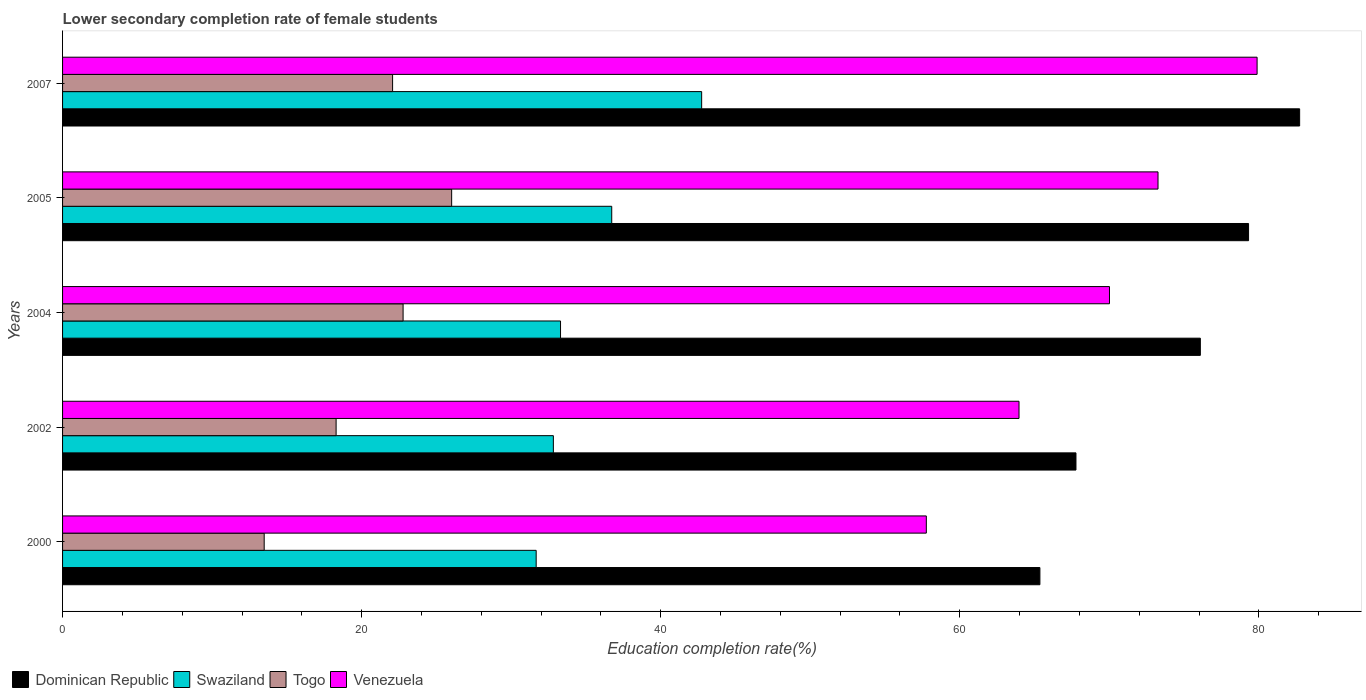How many different coloured bars are there?
Your answer should be very brief. 4. Are the number of bars per tick equal to the number of legend labels?
Give a very brief answer. Yes. Are the number of bars on each tick of the Y-axis equal?
Provide a short and direct response. Yes. How many bars are there on the 5th tick from the top?
Your answer should be very brief. 4. How many bars are there on the 5th tick from the bottom?
Keep it short and to the point. 4. In how many cases, is the number of bars for a given year not equal to the number of legend labels?
Offer a very short reply. 0. What is the lower secondary completion rate of female students in Swaziland in 2005?
Offer a terse response. 36.73. Across all years, what is the maximum lower secondary completion rate of female students in Venezuela?
Your answer should be compact. 79.89. Across all years, what is the minimum lower secondary completion rate of female students in Swaziland?
Ensure brevity in your answer.  31.67. What is the total lower secondary completion rate of female students in Swaziland in the graph?
Your answer should be compact. 177.26. What is the difference between the lower secondary completion rate of female students in Venezuela in 2000 and that in 2002?
Make the answer very short. -6.2. What is the difference between the lower secondary completion rate of female students in Togo in 2005 and the lower secondary completion rate of female students in Dominican Republic in 2002?
Ensure brevity in your answer.  -41.75. What is the average lower secondary completion rate of female students in Togo per year?
Offer a very short reply. 20.53. In the year 2005, what is the difference between the lower secondary completion rate of female students in Swaziland and lower secondary completion rate of female students in Venezuela?
Offer a very short reply. -36.53. In how many years, is the lower secondary completion rate of female students in Togo greater than 56 %?
Keep it short and to the point. 0. What is the ratio of the lower secondary completion rate of female students in Venezuela in 2000 to that in 2007?
Offer a terse response. 0.72. Is the difference between the lower secondary completion rate of female students in Swaziland in 2000 and 2005 greater than the difference between the lower secondary completion rate of female students in Venezuela in 2000 and 2005?
Offer a very short reply. Yes. What is the difference between the highest and the second highest lower secondary completion rate of female students in Venezuela?
Your answer should be compact. 6.63. What is the difference between the highest and the lowest lower secondary completion rate of female students in Dominican Republic?
Give a very brief answer. 17.37. In how many years, is the lower secondary completion rate of female students in Venezuela greater than the average lower secondary completion rate of female students in Venezuela taken over all years?
Ensure brevity in your answer.  3. Is it the case that in every year, the sum of the lower secondary completion rate of female students in Togo and lower secondary completion rate of female students in Venezuela is greater than the sum of lower secondary completion rate of female students in Swaziland and lower secondary completion rate of female students in Dominican Republic?
Your answer should be very brief. No. What does the 2nd bar from the top in 2004 represents?
Provide a succinct answer. Togo. What does the 2nd bar from the bottom in 2007 represents?
Give a very brief answer. Swaziland. Is it the case that in every year, the sum of the lower secondary completion rate of female students in Swaziland and lower secondary completion rate of female students in Togo is greater than the lower secondary completion rate of female students in Venezuela?
Ensure brevity in your answer.  No. Are all the bars in the graph horizontal?
Provide a succinct answer. Yes. Where does the legend appear in the graph?
Offer a very short reply. Bottom left. How many legend labels are there?
Provide a short and direct response. 4. How are the legend labels stacked?
Ensure brevity in your answer.  Horizontal. What is the title of the graph?
Offer a terse response. Lower secondary completion rate of female students. Does "Kiribati" appear as one of the legend labels in the graph?
Give a very brief answer. No. What is the label or title of the X-axis?
Your answer should be compact. Education completion rate(%). What is the Education completion rate(%) of Dominican Republic in 2000?
Provide a short and direct response. 65.36. What is the Education completion rate(%) in Swaziland in 2000?
Offer a very short reply. 31.67. What is the Education completion rate(%) in Togo in 2000?
Your answer should be very brief. 13.48. What is the Education completion rate(%) in Venezuela in 2000?
Your response must be concise. 57.76. What is the Education completion rate(%) in Dominican Republic in 2002?
Provide a short and direct response. 67.77. What is the Education completion rate(%) in Swaziland in 2002?
Your answer should be very brief. 32.82. What is the Education completion rate(%) of Togo in 2002?
Ensure brevity in your answer.  18.29. What is the Education completion rate(%) of Venezuela in 2002?
Make the answer very short. 63.96. What is the Education completion rate(%) of Dominican Republic in 2004?
Make the answer very short. 76.09. What is the Education completion rate(%) of Swaziland in 2004?
Your answer should be very brief. 33.3. What is the Education completion rate(%) in Togo in 2004?
Offer a terse response. 22.77. What is the Education completion rate(%) of Venezuela in 2004?
Offer a very short reply. 70.01. What is the Education completion rate(%) in Dominican Republic in 2005?
Provide a succinct answer. 79.31. What is the Education completion rate(%) in Swaziland in 2005?
Your answer should be compact. 36.73. What is the Education completion rate(%) of Togo in 2005?
Offer a very short reply. 26.02. What is the Education completion rate(%) in Venezuela in 2005?
Keep it short and to the point. 73.26. What is the Education completion rate(%) in Dominican Republic in 2007?
Provide a short and direct response. 82.73. What is the Education completion rate(%) in Swaziland in 2007?
Offer a terse response. 42.74. What is the Education completion rate(%) of Togo in 2007?
Provide a succinct answer. 22.07. What is the Education completion rate(%) in Venezuela in 2007?
Your answer should be very brief. 79.89. Across all years, what is the maximum Education completion rate(%) of Dominican Republic?
Provide a short and direct response. 82.73. Across all years, what is the maximum Education completion rate(%) of Swaziland?
Provide a succinct answer. 42.74. Across all years, what is the maximum Education completion rate(%) of Togo?
Make the answer very short. 26.02. Across all years, what is the maximum Education completion rate(%) in Venezuela?
Ensure brevity in your answer.  79.89. Across all years, what is the minimum Education completion rate(%) of Dominican Republic?
Ensure brevity in your answer.  65.36. Across all years, what is the minimum Education completion rate(%) of Swaziland?
Make the answer very short. 31.67. Across all years, what is the minimum Education completion rate(%) of Togo?
Provide a short and direct response. 13.48. Across all years, what is the minimum Education completion rate(%) of Venezuela?
Provide a succinct answer. 57.76. What is the total Education completion rate(%) of Dominican Republic in the graph?
Offer a very short reply. 371.27. What is the total Education completion rate(%) in Swaziland in the graph?
Your answer should be compact. 177.26. What is the total Education completion rate(%) of Togo in the graph?
Your answer should be very brief. 102.64. What is the total Education completion rate(%) in Venezuela in the graph?
Ensure brevity in your answer.  344.89. What is the difference between the Education completion rate(%) of Dominican Republic in 2000 and that in 2002?
Make the answer very short. -2.41. What is the difference between the Education completion rate(%) of Swaziland in 2000 and that in 2002?
Ensure brevity in your answer.  -1.15. What is the difference between the Education completion rate(%) of Togo in 2000 and that in 2002?
Provide a succinct answer. -4.81. What is the difference between the Education completion rate(%) in Venezuela in 2000 and that in 2002?
Give a very brief answer. -6.2. What is the difference between the Education completion rate(%) in Dominican Republic in 2000 and that in 2004?
Offer a very short reply. -10.73. What is the difference between the Education completion rate(%) in Swaziland in 2000 and that in 2004?
Make the answer very short. -1.63. What is the difference between the Education completion rate(%) of Togo in 2000 and that in 2004?
Offer a terse response. -9.29. What is the difference between the Education completion rate(%) in Venezuela in 2000 and that in 2004?
Your answer should be very brief. -12.25. What is the difference between the Education completion rate(%) in Dominican Republic in 2000 and that in 2005?
Your response must be concise. -13.95. What is the difference between the Education completion rate(%) of Swaziland in 2000 and that in 2005?
Your answer should be very brief. -5.05. What is the difference between the Education completion rate(%) of Togo in 2000 and that in 2005?
Offer a very short reply. -12.54. What is the difference between the Education completion rate(%) in Venezuela in 2000 and that in 2005?
Your answer should be very brief. -15.49. What is the difference between the Education completion rate(%) in Dominican Republic in 2000 and that in 2007?
Your answer should be compact. -17.37. What is the difference between the Education completion rate(%) in Swaziland in 2000 and that in 2007?
Offer a terse response. -11.07. What is the difference between the Education completion rate(%) in Togo in 2000 and that in 2007?
Keep it short and to the point. -8.59. What is the difference between the Education completion rate(%) in Venezuela in 2000 and that in 2007?
Give a very brief answer. -22.12. What is the difference between the Education completion rate(%) of Dominican Republic in 2002 and that in 2004?
Provide a short and direct response. -8.32. What is the difference between the Education completion rate(%) of Swaziland in 2002 and that in 2004?
Your answer should be very brief. -0.48. What is the difference between the Education completion rate(%) in Togo in 2002 and that in 2004?
Your answer should be very brief. -4.48. What is the difference between the Education completion rate(%) of Venezuela in 2002 and that in 2004?
Offer a very short reply. -6.05. What is the difference between the Education completion rate(%) of Dominican Republic in 2002 and that in 2005?
Give a very brief answer. -11.54. What is the difference between the Education completion rate(%) in Swaziland in 2002 and that in 2005?
Offer a very short reply. -3.9. What is the difference between the Education completion rate(%) of Togo in 2002 and that in 2005?
Give a very brief answer. -7.73. What is the difference between the Education completion rate(%) in Venezuela in 2002 and that in 2005?
Provide a succinct answer. -9.3. What is the difference between the Education completion rate(%) of Dominican Republic in 2002 and that in 2007?
Make the answer very short. -14.96. What is the difference between the Education completion rate(%) in Swaziland in 2002 and that in 2007?
Offer a terse response. -9.92. What is the difference between the Education completion rate(%) in Togo in 2002 and that in 2007?
Give a very brief answer. -3.78. What is the difference between the Education completion rate(%) of Venezuela in 2002 and that in 2007?
Offer a terse response. -15.92. What is the difference between the Education completion rate(%) of Dominican Republic in 2004 and that in 2005?
Your answer should be very brief. -3.23. What is the difference between the Education completion rate(%) in Swaziland in 2004 and that in 2005?
Give a very brief answer. -3.42. What is the difference between the Education completion rate(%) in Togo in 2004 and that in 2005?
Make the answer very short. -3.25. What is the difference between the Education completion rate(%) in Venezuela in 2004 and that in 2005?
Make the answer very short. -3.24. What is the difference between the Education completion rate(%) of Dominican Republic in 2004 and that in 2007?
Your response must be concise. -6.64. What is the difference between the Education completion rate(%) of Swaziland in 2004 and that in 2007?
Your response must be concise. -9.44. What is the difference between the Education completion rate(%) of Togo in 2004 and that in 2007?
Offer a terse response. 0.7. What is the difference between the Education completion rate(%) in Venezuela in 2004 and that in 2007?
Your answer should be compact. -9.87. What is the difference between the Education completion rate(%) of Dominican Republic in 2005 and that in 2007?
Offer a terse response. -3.42. What is the difference between the Education completion rate(%) of Swaziland in 2005 and that in 2007?
Your response must be concise. -6.01. What is the difference between the Education completion rate(%) of Togo in 2005 and that in 2007?
Provide a short and direct response. 3.95. What is the difference between the Education completion rate(%) of Venezuela in 2005 and that in 2007?
Keep it short and to the point. -6.63. What is the difference between the Education completion rate(%) of Dominican Republic in 2000 and the Education completion rate(%) of Swaziland in 2002?
Provide a short and direct response. 32.54. What is the difference between the Education completion rate(%) in Dominican Republic in 2000 and the Education completion rate(%) in Togo in 2002?
Offer a terse response. 47.07. What is the difference between the Education completion rate(%) in Dominican Republic in 2000 and the Education completion rate(%) in Venezuela in 2002?
Your answer should be compact. 1.4. What is the difference between the Education completion rate(%) of Swaziland in 2000 and the Education completion rate(%) of Togo in 2002?
Offer a terse response. 13.38. What is the difference between the Education completion rate(%) in Swaziland in 2000 and the Education completion rate(%) in Venezuela in 2002?
Provide a succinct answer. -32.29. What is the difference between the Education completion rate(%) in Togo in 2000 and the Education completion rate(%) in Venezuela in 2002?
Provide a succinct answer. -50.48. What is the difference between the Education completion rate(%) in Dominican Republic in 2000 and the Education completion rate(%) in Swaziland in 2004?
Your answer should be compact. 32.06. What is the difference between the Education completion rate(%) in Dominican Republic in 2000 and the Education completion rate(%) in Togo in 2004?
Provide a succinct answer. 42.59. What is the difference between the Education completion rate(%) in Dominican Republic in 2000 and the Education completion rate(%) in Venezuela in 2004?
Offer a terse response. -4.65. What is the difference between the Education completion rate(%) in Swaziland in 2000 and the Education completion rate(%) in Togo in 2004?
Provide a succinct answer. 8.9. What is the difference between the Education completion rate(%) of Swaziland in 2000 and the Education completion rate(%) of Venezuela in 2004?
Give a very brief answer. -38.34. What is the difference between the Education completion rate(%) in Togo in 2000 and the Education completion rate(%) in Venezuela in 2004?
Provide a succinct answer. -56.53. What is the difference between the Education completion rate(%) of Dominican Republic in 2000 and the Education completion rate(%) of Swaziland in 2005?
Your answer should be compact. 28.63. What is the difference between the Education completion rate(%) of Dominican Republic in 2000 and the Education completion rate(%) of Togo in 2005?
Offer a very short reply. 39.34. What is the difference between the Education completion rate(%) in Dominican Republic in 2000 and the Education completion rate(%) in Venezuela in 2005?
Keep it short and to the point. -7.9. What is the difference between the Education completion rate(%) of Swaziland in 2000 and the Education completion rate(%) of Togo in 2005?
Offer a terse response. 5.65. What is the difference between the Education completion rate(%) of Swaziland in 2000 and the Education completion rate(%) of Venezuela in 2005?
Your answer should be compact. -41.59. What is the difference between the Education completion rate(%) in Togo in 2000 and the Education completion rate(%) in Venezuela in 2005?
Keep it short and to the point. -59.77. What is the difference between the Education completion rate(%) of Dominican Republic in 2000 and the Education completion rate(%) of Swaziland in 2007?
Make the answer very short. 22.62. What is the difference between the Education completion rate(%) of Dominican Republic in 2000 and the Education completion rate(%) of Togo in 2007?
Keep it short and to the point. 43.29. What is the difference between the Education completion rate(%) in Dominican Republic in 2000 and the Education completion rate(%) in Venezuela in 2007?
Ensure brevity in your answer.  -14.53. What is the difference between the Education completion rate(%) of Swaziland in 2000 and the Education completion rate(%) of Togo in 2007?
Offer a very short reply. 9.6. What is the difference between the Education completion rate(%) of Swaziland in 2000 and the Education completion rate(%) of Venezuela in 2007?
Your answer should be compact. -48.21. What is the difference between the Education completion rate(%) in Togo in 2000 and the Education completion rate(%) in Venezuela in 2007?
Keep it short and to the point. -66.4. What is the difference between the Education completion rate(%) of Dominican Republic in 2002 and the Education completion rate(%) of Swaziland in 2004?
Make the answer very short. 34.47. What is the difference between the Education completion rate(%) of Dominican Republic in 2002 and the Education completion rate(%) of Togo in 2004?
Offer a terse response. 45. What is the difference between the Education completion rate(%) in Dominican Republic in 2002 and the Education completion rate(%) in Venezuela in 2004?
Ensure brevity in your answer.  -2.24. What is the difference between the Education completion rate(%) of Swaziland in 2002 and the Education completion rate(%) of Togo in 2004?
Provide a succinct answer. 10.05. What is the difference between the Education completion rate(%) of Swaziland in 2002 and the Education completion rate(%) of Venezuela in 2004?
Offer a terse response. -37.19. What is the difference between the Education completion rate(%) of Togo in 2002 and the Education completion rate(%) of Venezuela in 2004?
Offer a terse response. -51.72. What is the difference between the Education completion rate(%) in Dominican Republic in 2002 and the Education completion rate(%) in Swaziland in 2005?
Ensure brevity in your answer.  31.05. What is the difference between the Education completion rate(%) in Dominican Republic in 2002 and the Education completion rate(%) in Togo in 2005?
Your response must be concise. 41.75. What is the difference between the Education completion rate(%) in Dominican Republic in 2002 and the Education completion rate(%) in Venezuela in 2005?
Provide a succinct answer. -5.49. What is the difference between the Education completion rate(%) in Swaziland in 2002 and the Education completion rate(%) in Togo in 2005?
Provide a short and direct response. 6.8. What is the difference between the Education completion rate(%) in Swaziland in 2002 and the Education completion rate(%) in Venezuela in 2005?
Your answer should be compact. -40.44. What is the difference between the Education completion rate(%) in Togo in 2002 and the Education completion rate(%) in Venezuela in 2005?
Offer a terse response. -54.97. What is the difference between the Education completion rate(%) in Dominican Republic in 2002 and the Education completion rate(%) in Swaziland in 2007?
Make the answer very short. 25.03. What is the difference between the Education completion rate(%) in Dominican Republic in 2002 and the Education completion rate(%) in Togo in 2007?
Keep it short and to the point. 45.7. What is the difference between the Education completion rate(%) in Dominican Republic in 2002 and the Education completion rate(%) in Venezuela in 2007?
Make the answer very short. -12.11. What is the difference between the Education completion rate(%) in Swaziland in 2002 and the Education completion rate(%) in Togo in 2007?
Ensure brevity in your answer.  10.75. What is the difference between the Education completion rate(%) of Swaziland in 2002 and the Education completion rate(%) of Venezuela in 2007?
Give a very brief answer. -47.06. What is the difference between the Education completion rate(%) of Togo in 2002 and the Education completion rate(%) of Venezuela in 2007?
Your answer should be compact. -61.59. What is the difference between the Education completion rate(%) in Dominican Republic in 2004 and the Education completion rate(%) in Swaziland in 2005?
Provide a succinct answer. 39.36. What is the difference between the Education completion rate(%) of Dominican Republic in 2004 and the Education completion rate(%) of Togo in 2005?
Give a very brief answer. 50.07. What is the difference between the Education completion rate(%) in Dominican Republic in 2004 and the Education completion rate(%) in Venezuela in 2005?
Provide a short and direct response. 2.83. What is the difference between the Education completion rate(%) in Swaziland in 2004 and the Education completion rate(%) in Togo in 2005?
Provide a short and direct response. 7.28. What is the difference between the Education completion rate(%) of Swaziland in 2004 and the Education completion rate(%) of Venezuela in 2005?
Offer a very short reply. -39.96. What is the difference between the Education completion rate(%) in Togo in 2004 and the Education completion rate(%) in Venezuela in 2005?
Offer a terse response. -50.49. What is the difference between the Education completion rate(%) in Dominican Republic in 2004 and the Education completion rate(%) in Swaziland in 2007?
Make the answer very short. 33.35. What is the difference between the Education completion rate(%) of Dominican Republic in 2004 and the Education completion rate(%) of Togo in 2007?
Keep it short and to the point. 54.02. What is the difference between the Education completion rate(%) in Dominican Republic in 2004 and the Education completion rate(%) in Venezuela in 2007?
Ensure brevity in your answer.  -3.8. What is the difference between the Education completion rate(%) of Swaziland in 2004 and the Education completion rate(%) of Togo in 2007?
Make the answer very short. 11.23. What is the difference between the Education completion rate(%) of Swaziland in 2004 and the Education completion rate(%) of Venezuela in 2007?
Your answer should be compact. -46.58. What is the difference between the Education completion rate(%) in Togo in 2004 and the Education completion rate(%) in Venezuela in 2007?
Your response must be concise. -57.11. What is the difference between the Education completion rate(%) in Dominican Republic in 2005 and the Education completion rate(%) in Swaziland in 2007?
Offer a terse response. 36.58. What is the difference between the Education completion rate(%) of Dominican Republic in 2005 and the Education completion rate(%) of Togo in 2007?
Ensure brevity in your answer.  57.24. What is the difference between the Education completion rate(%) in Dominican Republic in 2005 and the Education completion rate(%) in Venezuela in 2007?
Your response must be concise. -0.57. What is the difference between the Education completion rate(%) in Swaziland in 2005 and the Education completion rate(%) in Togo in 2007?
Make the answer very short. 14.66. What is the difference between the Education completion rate(%) of Swaziland in 2005 and the Education completion rate(%) of Venezuela in 2007?
Provide a short and direct response. -43.16. What is the difference between the Education completion rate(%) of Togo in 2005 and the Education completion rate(%) of Venezuela in 2007?
Provide a short and direct response. -53.87. What is the average Education completion rate(%) in Dominican Republic per year?
Ensure brevity in your answer.  74.25. What is the average Education completion rate(%) of Swaziland per year?
Provide a short and direct response. 35.45. What is the average Education completion rate(%) in Togo per year?
Your answer should be very brief. 20.53. What is the average Education completion rate(%) of Venezuela per year?
Provide a short and direct response. 68.98. In the year 2000, what is the difference between the Education completion rate(%) of Dominican Republic and Education completion rate(%) of Swaziland?
Give a very brief answer. 33.69. In the year 2000, what is the difference between the Education completion rate(%) of Dominican Republic and Education completion rate(%) of Togo?
Your answer should be compact. 51.88. In the year 2000, what is the difference between the Education completion rate(%) of Dominican Republic and Education completion rate(%) of Venezuela?
Provide a short and direct response. 7.6. In the year 2000, what is the difference between the Education completion rate(%) in Swaziland and Education completion rate(%) in Togo?
Give a very brief answer. 18.19. In the year 2000, what is the difference between the Education completion rate(%) of Swaziland and Education completion rate(%) of Venezuela?
Your response must be concise. -26.09. In the year 2000, what is the difference between the Education completion rate(%) of Togo and Education completion rate(%) of Venezuela?
Your answer should be very brief. -44.28. In the year 2002, what is the difference between the Education completion rate(%) in Dominican Republic and Education completion rate(%) in Swaziland?
Offer a terse response. 34.95. In the year 2002, what is the difference between the Education completion rate(%) in Dominican Republic and Education completion rate(%) in Togo?
Your answer should be compact. 49.48. In the year 2002, what is the difference between the Education completion rate(%) of Dominican Republic and Education completion rate(%) of Venezuela?
Keep it short and to the point. 3.81. In the year 2002, what is the difference between the Education completion rate(%) of Swaziland and Education completion rate(%) of Togo?
Make the answer very short. 14.53. In the year 2002, what is the difference between the Education completion rate(%) in Swaziland and Education completion rate(%) in Venezuela?
Give a very brief answer. -31.14. In the year 2002, what is the difference between the Education completion rate(%) in Togo and Education completion rate(%) in Venezuela?
Your answer should be very brief. -45.67. In the year 2004, what is the difference between the Education completion rate(%) of Dominican Republic and Education completion rate(%) of Swaziland?
Offer a very short reply. 42.79. In the year 2004, what is the difference between the Education completion rate(%) of Dominican Republic and Education completion rate(%) of Togo?
Ensure brevity in your answer.  53.32. In the year 2004, what is the difference between the Education completion rate(%) of Dominican Republic and Education completion rate(%) of Venezuela?
Your response must be concise. 6.08. In the year 2004, what is the difference between the Education completion rate(%) of Swaziland and Education completion rate(%) of Togo?
Offer a very short reply. 10.53. In the year 2004, what is the difference between the Education completion rate(%) in Swaziland and Education completion rate(%) in Venezuela?
Make the answer very short. -36.71. In the year 2004, what is the difference between the Education completion rate(%) in Togo and Education completion rate(%) in Venezuela?
Offer a terse response. -47.24. In the year 2005, what is the difference between the Education completion rate(%) of Dominican Republic and Education completion rate(%) of Swaziland?
Make the answer very short. 42.59. In the year 2005, what is the difference between the Education completion rate(%) of Dominican Republic and Education completion rate(%) of Togo?
Your answer should be very brief. 53.29. In the year 2005, what is the difference between the Education completion rate(%) in Dominican Republic and Education completion rate(%) in Venezuela?
Provide a short and direct response. 6.06. In the year 2005, what is the difference between the Education completion rate(%) of Swaziland and Education completion rate(%) of Togo?
Your answer should be very brief. 10.71. In the year 2005, what is the difference between the Education completion rate(%) of Swaziland and Education completion rate(%) of Venezuela?
Offer a very short reply. -36.53. In the year 2005, what is the difference between the Education completion rate(%) in Togo and Education completion rate(%) in Venezuela?
Ensure brevity in your answer.  -47.24. In the year 2007, what is the difference between the Education completion rate(%) in Dominican Republic and Education completion rate(%) in Swaziland?
Your response must be concise. 39.99. In the year 2007, what is the difference between the Education completion rate(%) in Dominican Republic and Education completion rate(%) in Togo?
Provide a succinct answer. 60.66. In the year 2007, what is the difference between the Education completion rate(%) of Dominican Republic and Education completion rate(%) of Venezuela?
Offer a terse response. 2.85. In the year 2007, what is the difference between the Education completion rate(%) of Swaziland and Education completion rate(%) of Togo?
Provide a short and direct response. 20.67. In the year 2007, what is the difference between the Education completion rate(%) of Swaziland and Education completion rate(%) of Venezuela?
Your answer should be very brief. -37.15. In the year 2007, what is the difference between the Education completion rate(%) in Togo and Education completion rate(%) in Venezuela?
Provide a short and direct response. -57.81. What is the ratio of the Education completion rate(%) of Dominican Republic in 2000 to that in 2002?
Provide a succinct answer. 0.96. What is the ratio of the Education completion rate(%) in Togo in 2000 to that in 2002?
Make the answer very short. 0.74. What is the ratio of the Education completion rate(%) in Venezuela in 2000 to that in 2002?
Your response must be concise. 0.9. What is the ratio of the Education completion rate(%) in Dominican Republic in 2000 to that in 2004?
Ensure brevity in your answer.  0.86. What is the ratio of the Education completion rate(%) in Swaziland in 2000 to that in 2004?
Your answer should be compact. 0.95. What is the ratio of the Education completion rate(%) in Togo in 2000 to that in 2004?
Your response must be concise. 0.59. What is the ratio of the Education completion rate(%) in Venezuela in 2000 to that in 2004?
Give a very brief answer. 0.82. What is the ratio of the Education completion rate(%) in Dominican Republic in 2000 to that in 2005?
Offer a terse response. 0.82. What is the ratio of the Education completion rate(%) in Swaziland in 2000 to that in 2005?
Provide a succinct answer. 0.86. What is the ratio of the Education completion rate(%) of Togo in 2000 to that in 2005?
Your answer should be very brief. 0.52. What is the ratio of the Education completion rate(%) of Venezuela in 2000 to that in 2005?
Your answer should be very brief. 0.79. What is the ratio of the Education completion rate(%) in Dominican Republic in 2000 to that in 2007?
Your response must be concise. 0.79. What is the ratio of the Education completion rate(%) in Swaziland in 2000 to that in 2007?
Ensure brevity in your answer.  0.74. What is the ratio of the Education completion rate(%) in Togo in 2000 to that in 2007?
Give a very brief answer. 0.61. What is the ratio of the Education completion rate(%) of Venezuela in 2000 to that in 2007?
Provide a short and direct response. 0.72. What is the ratio of the Education completion rate(%) in Dominican Republic in 2002 to that in 2004?
Your answer should be compact. 0.89. What is the ratio of the Education completion rate(%) of Swaziland in 2002 to that in 2004?
Offer a very short reply. 0.99. What is the ratio of the Education completion rate(%) in Togo in 2002 to that in 2004?
Give a very brief answer. 0.8. What is the ratio of the Education completion rate(%) in Venezuela in 2002 to that in 2004?
Offer a terse response. 0.91. What is the ratio of the Education completion rate(%) of Dominican Republic in 2002 to that in 2005?
Offer a terse response. 0.85. What is the ratio of the Education completion rate(%) in Swaziland in 2002 to that in 2005?
Keep it short and to the point. 0.89. What is the ratio of the Education completion rate(%) of Togo in 2002 to that in 2005?
Your answer should be compact. 0.7. What is the ratio of the Education completion rate(%) in Venezuela in 2002 to that in 2005?
Provide a short and direct response. 0.87. What is the ratio of the Education completion rate(%) of Dominican Republic in 2002 to that in 2007?
Ensure brevity in your answer.  0.82. What is the ratio of the Education completion rate(%) of Swaziland in 2002 to that in 2007?
Make the answer very short. 0.77. What is the ratio of the Education completion rate(%) of Togo in 2002 to that in 2007?
Give a very brief answer. 0.83. What is the ratio of the Education completion rate(%) in Venezuela in 2002 to that in 2007?
Provide a short and direct response. 0.8. What is the ratio of the Education completion rate(%) of Dominican Republic in 2004 to that in 2005?
Provide a succinct answer. 0.96. What is the ratio of the Education completion rate(%) in Swaziland in 2004 to that in 2005?
Your response must be concise. 0.91. What is the ratio of the Education completion rate(%) in Togo in 2004 to that in 2005?
Give a very brief answer. 0.88. What is the ratio of the Education completion rate(%) in Venezuela in 2004 to that in 2005?
Offer a very short reply. 0.96. What is the ratio of the Education completion rate(%) of Dominican Republic in 2004 to that in 2007?
Give a very brief answer. 0.92. What is the ratio of the Education completion rate(%) in Swaziland in 2004 to that in 2007?
Provide a short and direct response. 0.78. What is the ratio of the Education completion rate(%) of Togo in 2004 to that in 2007?
Make the answer very short. 1.03. What is the ratio of the Education completion rate(%) in Venezuela in 2004 to that in 2007?
Offer a terse response. 0.88. What is the ratio of the Education completion rate(%) of Dominican Republic in 2005 to that in 2007?
Your response must be concise. 0.96. What is the ratio of the Education completion rate(%) in Swaziland in 2005 to that in 2007?
Keep it short and to the point. 0.86. What is the ratio of the Education completion rate(%) in Togo in 2005 to that in 2007?
Keep it short and to the point. 1.18. What is the ratio of the Education completion rate(%) in Venezuela in 2005 to that in 2007?
Provide a succinct answer. 0.92. What is the difference between the highest and the second highest Education completion rate(%) of Dominican Republic?
Your answer should be compact. 3.42. What is the difference between the highest and the second highest Education completion rate(%) of Swaziland?
Ensure brevity in your answer.  6.01. What is the difference between the highest and the second highest Education completion rate(%) of Togo?
Offer a terse response. 3.25. What is the difference between the highest and the second highest Education completion rate(%) in Venezuela?
Keep it short and to the point. 6.63. What is the difference between the highest and the lowest Education completion rate(%) in Dominican Republic?
Offer a terse response. 17.37. What is the difference between the highest and the lowest Education completion rate(%) in Swaziland?
Your response must be concise. 11.07. What is the difference between the highest and the lowest Education completion rate(%) of Togo?
Provide a short and direct response. 12.54. What is the difference between the highest and the lowest Education completion rate(%) in Venezuela?
Provide a short and direct response. 22.12. 